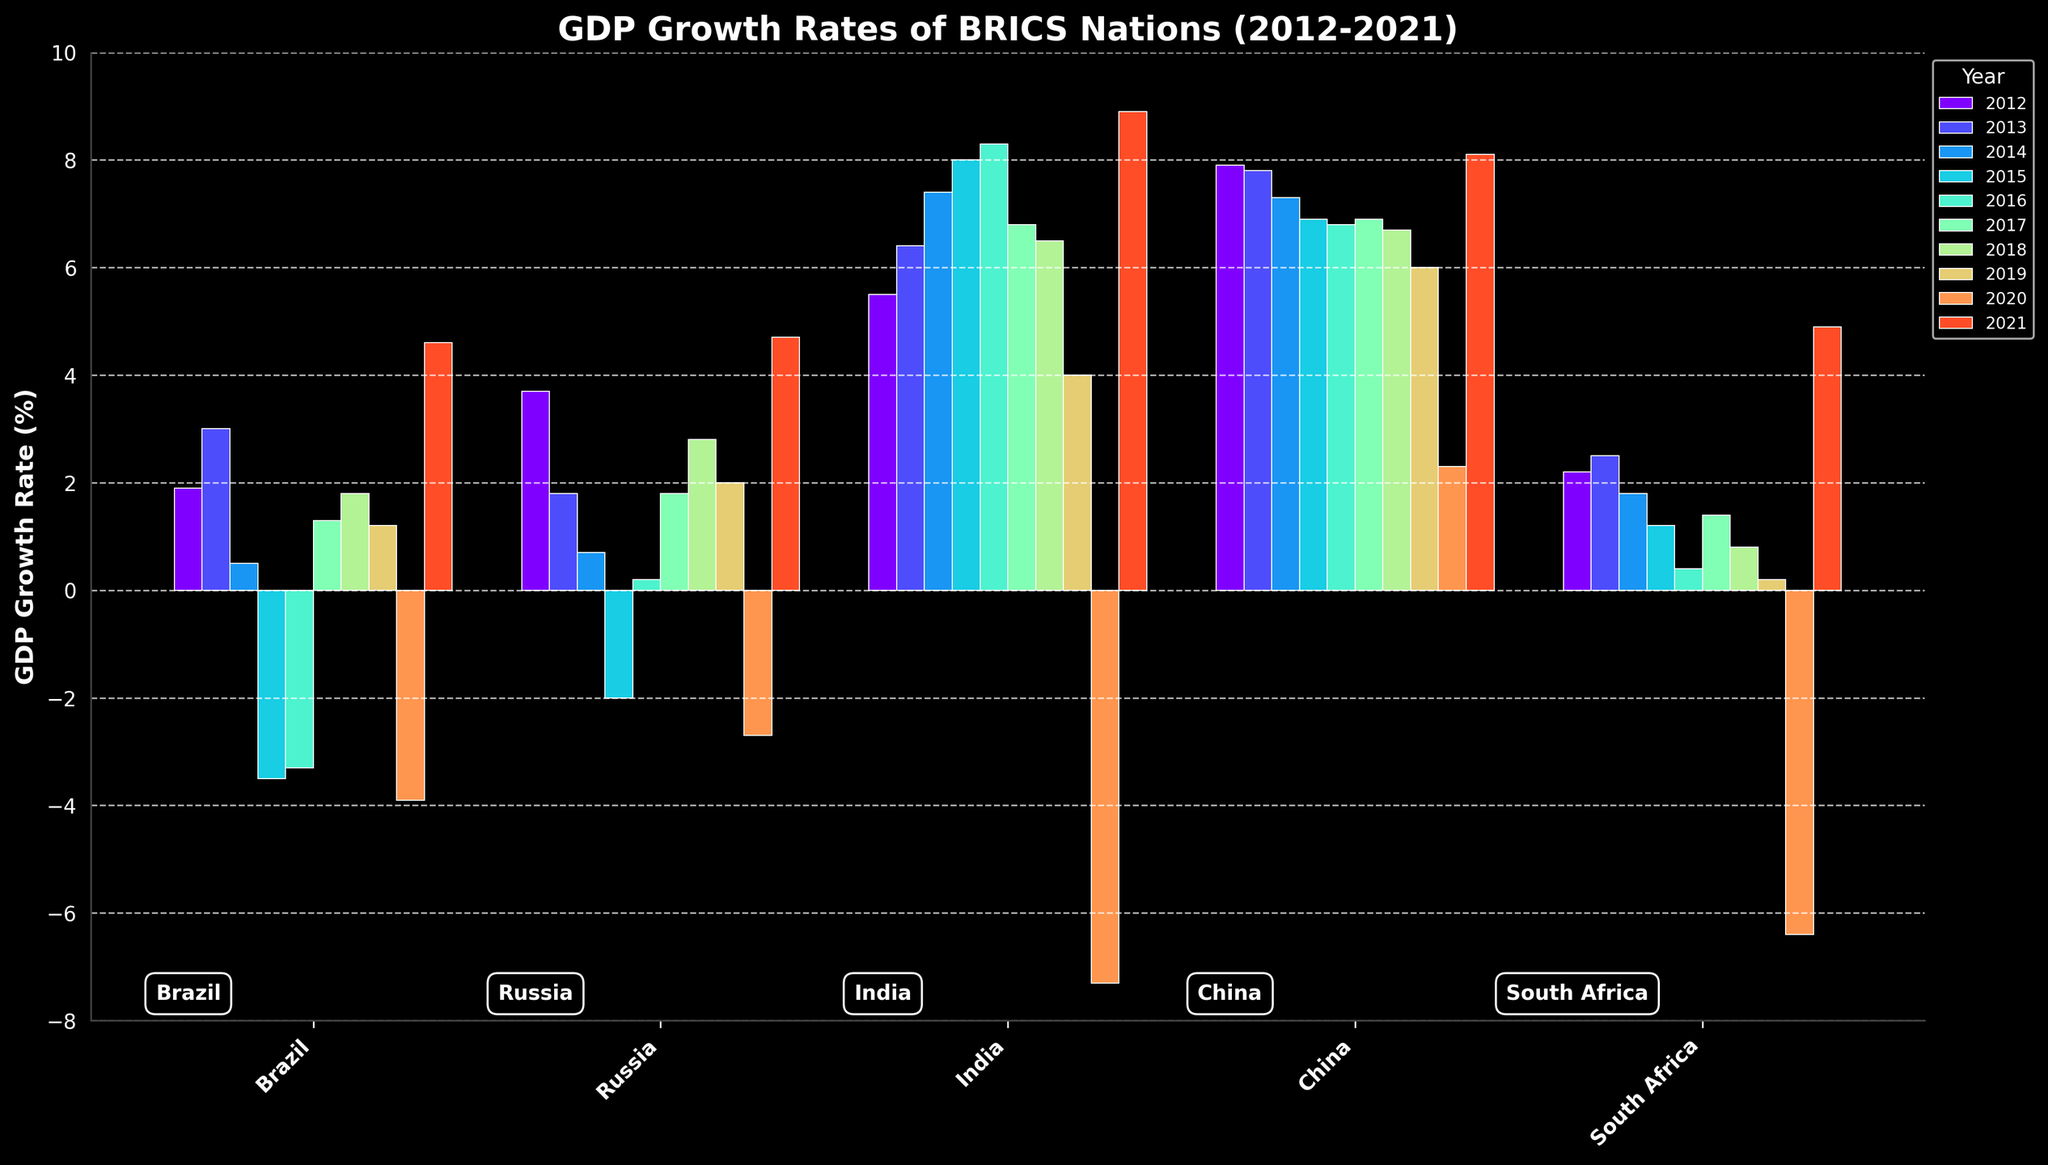How did the GDP growth rate of Brazil vary from 2015 to 2016? In the bar chart, locate the bars corresponding to Brazil for the years 2015 and 2016. The GDP growth rate for Brazil in 2015 is -3.5%, and for 2016, it is -3.3%. To find the variation, subtract the 2015 value from the 2016 value, which is (-3.3) - (-3.5) = 0.2%.
Answer: 0.2% Which country had the highest GDP growth rate in 2020 and what was the value? In the bar chart, look at the bars for the year 2020 across all the BRICS nations. China had the highest GDP growth rate in 2020 with a value of 2.3%.
Answer: China, 2.3% Compare the GDP growth rates of India and Russia in 2021. Which country performed better and by how much? Locate the bars for India and Russia in the year 2021. India's GDP growth rate in 2021 is 8.9%, while Russia's GDP growth rate is 4.7%. Subtract Russia's value from India's value to determine the difference, which is 8.9 - 4.7 = 4.2%. India performed better by 4.2%.
Answer: India, 4.2% What is the average GDP growth rate of South Africa over the decade? Sum the GDP growth rates of South Africa for each year from 2012 to 2021, and then divide by the number of years (10). The values are 2.2, 2.5, 1.8, 1.2, 0.4, 1.4, 0.8, 0.2, -6.4, and 4.9. Summing these gives 9.0, and dividing by 10 gives 0.9%.
Answer: 0.9% Which year had the most negative GDP growth rate for Brazil, and what was the rate? Look for the most negative bar for Brazil across all the years. The lowest value for Brazil is in 2020 with a rate of -3.9%.
Answer: 2020, -3.9% Which country had the most consistent GDP growth rates from 2012 to 2021? Examine the bars' heights for each country over the years. China appears to have the least fluctuation as its GDP growth rates are relatively close to each other across the years, mostly staying around 6-8%.
Answer: China During which year did Russia have a negative GDP growth rate, and what was the rate? Look through the bars representing Russia for any negative bars. The years with negative GDP growth rates for Russia are 2015 with -2.0% and 2020 with -2.7%.
Answer: 2015, 2020 Which year had the highest GDP growth rate among all BRICS nations, and which country achieved it? Compare the tallest bars in each year for all BRICS nations. The highest GDP growth rate is achieved by India in 2021 with a rate of 8.9%.
Answer: 2021, India Did South Africa experience a positive GDP growth rate in 2015? Check the bar representing South Africa for the year 2015. The height of the bar shows a positive GDP growth rate of 1.2% in 2015.
Answer: Yes, 1.2% How many countries experienced negative GDP growth in 2020, and which ones were they? Identify the bars for the year 2020 that fall below the 0% mark. The countries with negative GDP growth in 2020 are Brazil (-3.9%), Russia (-2.7%), South Africa (-6.4%), and India (-7.3%). Four countries experienced negative growth.
Answer: 4 countries, Brazil, Russia, South Africa, India 